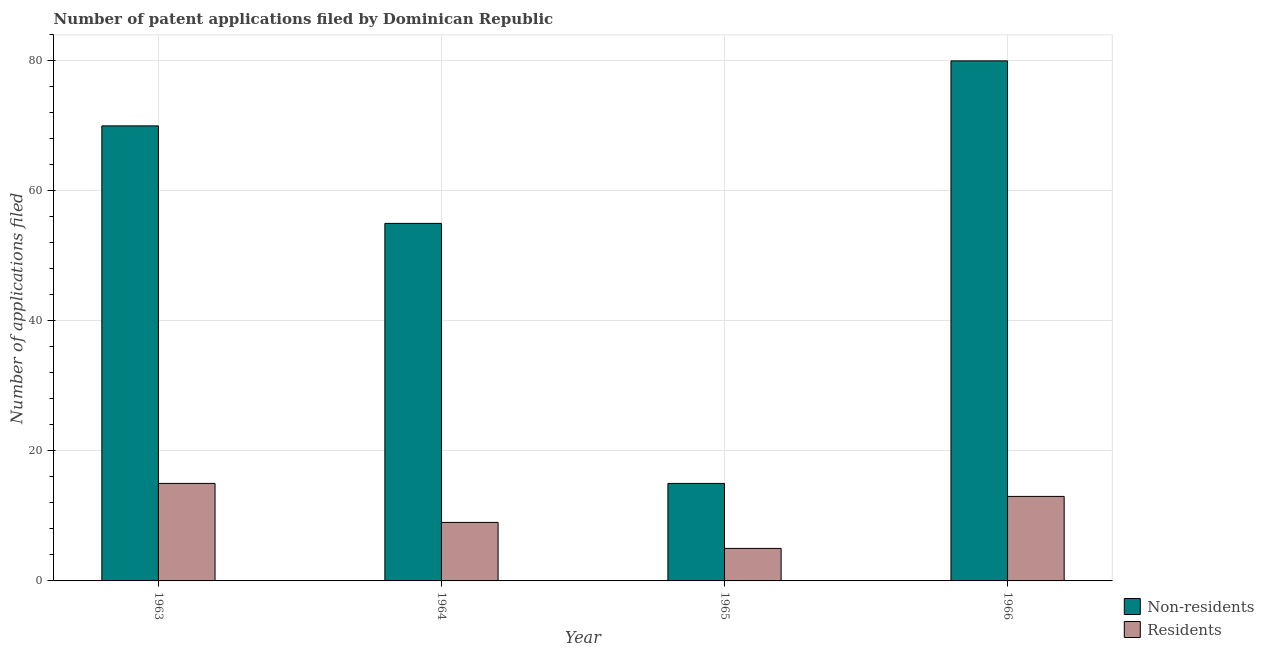How many different coloured bars are there?
Make the answer very short. 2. How many bars are there on the 4th tick from the right?
Provide a short and direct response. 2. What is the label of the 2nd group of bars from the left?
Give a very brief answer. 1964. What is the number of patent applications by non residents in 1964?
Keep it short and to the point. 55. Across all years, what is the maximum number of patent applications by residents?
Ensure brevity in your answer.  15. Across all years, what is the minimum number of patent applications by residents?
Ensure brevity in your answer.  5. In which year was the number of patent applications by non residents maximum?
Provide a short and direct response. 1966. In which year was the number of patent applications by non residents minimum?
Your response must be concise. 1965. What is the total number of patent applications by non residents in the graph?
Your answer should be compact. 220. What is the difference between the number of patent applications by residents in 1963 and that in 1964?
Ensure brevity in your answer.  6. What is the difference between the number of patent applications by residents in 1965 and the number of patent applications by non residents in 1964?
Offer a terse response. -4. What is the average number of patent applications by non residents per year?
Give a very brief answer. 55. In the year 1964, what is the difference between the number of patent applications by non residents and number of patent applications by residents?
Offer a very short reply. 0. In how many years, is the number of patent applications by residents greater than 4?
Provide a short and direct response. 4. What is the ratio of the number of patent applications by non residents in 1963 to that in 1964?
Offer a very short reply. 1.27. Is the number of patent applications by non residents in 1965 less than that in 1966?
Make the answer very short. Yes. What is the difference between the highest and the second highest number of patent applications by residents?
Your answer should be compact. 2. What is the difference between the highest and the lowest number of patent applications by non residents?
Offer a very short reply. 65. What does the 2nd bar from the left in 1966 represents?
Offer a terse response. Residents. What does the 2nd bar from the right in 1964 represents?
Offer a terse response. Non-residents. How many bars are there?
Make the answer very short. 8. How many years are there in the graph?
Offer a very short reply. 4. Does the graph contain any zero values?
Your answer should be very brief. No. Does the graph contain grids?
Make the answer very short. Yes. How many legend labels are there?
Give a very brief answer. 2. How are the legend labels stacked?
Keep it short and to the point. Vertical. What is the title of the graph?
Offer a terse response. Number of patent applications filed by Dominican Republic. What is the label or title of the Y-axis?
Your answer should be very brief. Number of applications filed. What is the Number of applications filed of Residents in 1963?
Provide a short and direct response. 15. What is the Number of applications filed in Non-residents in 1966?
Your answer should be very brief. 80. Across all years, what is the maximum Number of applications filed of Non-residents?
Ensure brevity in your answer.  80. Across all years, what is the minimum Number of applications filed in Residents?
Keep it short and to the point. 5. What is the total Number of applications filed of Non-residents in the graph?
Make the answer very short. 220. What is the total Number of applications filed of Residents in the graph?
Give a very brief answer. 42. What is the difference between the Number of applications filed of Non-residents in 1963 and that in 1964?
Your answer should be very brief. 15. What is the difference between the Number of applications filed of Non-residents in 1963 and that in 1965?
Give a very brief answer. 55. What is the difference between the Number of applications filed of Non-residents in 1963 and that in 1966?
Your answer should be very brief. -10. What is the difference between the Number of applications filed in Residents in 1963 and that in 1966?
Provide a succinct answer. 2. What is the difference between the Number of applications filed of Non-residents in 1964 and that in 1965?
Your answer should be compact. 40. What is the difference between the Number of applications filed of Non-residents in 1964 and that in 1966?
Provide a short and direct response. -25. What is the difference between the Number of applications filed in Residents in 1964 and that in 1966?
Keep it short and to the point. -4. What is the difference between the Number of applications filed in Non-residents in 1965 and that in 1966?
Keep it short and to the point. -65. What is the difference between the Number of applications filed of Residents in 1965 and that in 1966?
Your answer should be very brief. -8. What is the difference between the Number of applications filed of Non-residents in 1963 and the Number of applications filed of Residents in 1965?
Give a very brief answer. 65. What is the difference between the Number of applications filed of Non-residents in 1963 and the Number of applications filed of Residents in 1966?
Offer a very short reply. 57. What is the difference between the Number of applications filed in Non-residents in 1964 and the Number of applications filed in Residents in 1965?
Your answer should be compact. 50. What is the average Number of applications filed in Non-residents per year?
Make the answer very short. 55. What is the average Number of applications filed of Residents per year?
Provide a succinct answer. 10.5. In the year 1963, what is the difference between the Number of applications filed in Non-residents and Number of applications filed in Residents?
Ensure brevity in your answer.  55. In the year 1964, what is the difference between the Number of applications filed of Non-residents and Number of applications filed of Residents?
Provide a short and direct response. 46. In the year 1966, what is the difference between the Number of applications filed of Non-residents and Number of applications filed of Residents?
Offer a terse response. 67. What is the ratio of the Number of applications filed of Non-residents in 1963 to that in 1964?
Your answer should be compact. 1.27. What is the ratio of the Number of applications filed in Residents in 1963 to that in 1964?
Offer a very short reply. 1.67. What is the ratio of the Number of applications filed of Non-residents in 1963 to that in 1965?
Your answer should be very brief. 4.67. What is the ratio of the Number of applications filed in Residents in 1963 to that in 1965?
Your response must be concise. 3. What is the ratio of the Number of applications filed of Non-residents in 1963 to that in 1966?
Make the answer very short. 0.88. What is the ratio of the Number of applications filed in Residents in 1963 to that in 1966?
Offer a terse response. 1.15. What is the ratio of the Number of applications filed of Non-residents in 1964 to that in 1965?
Your answer should be compact. 3.67. What is the ratio of the Number of applications filed of Residents in 1964 to that in 1965?
Keep it short and to the point. 1.8. What is the ratio of the Number of applications filed of Non-residents in 1964 to that in 1966?
Provide a succinct answer. 0.69. What is the ratio of the Number of applications filed in Residents in 1964 to that in 1966?
Keep it short and to the point. 0.69. What is the ratio of the Number of applications filed in Non-residents in 1965 to that in 1966?
Provide a succinct answer. 0.19. What is the ratio of the Number of applications filed of Residents in 1965 to that in 1966?
Your response must be concise. 0.38. What is the difference between the highest and the lowest Number of applications filed of Non-residents?
Make the answer very short. 65. What is the difference between the highest and the lowest Number of applications filed in Residents?
Ensure brevity in your answer.  10. 